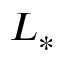<formula> <loc_0><loc_0><loc_500><loc_500>L _ { * }</formula> 